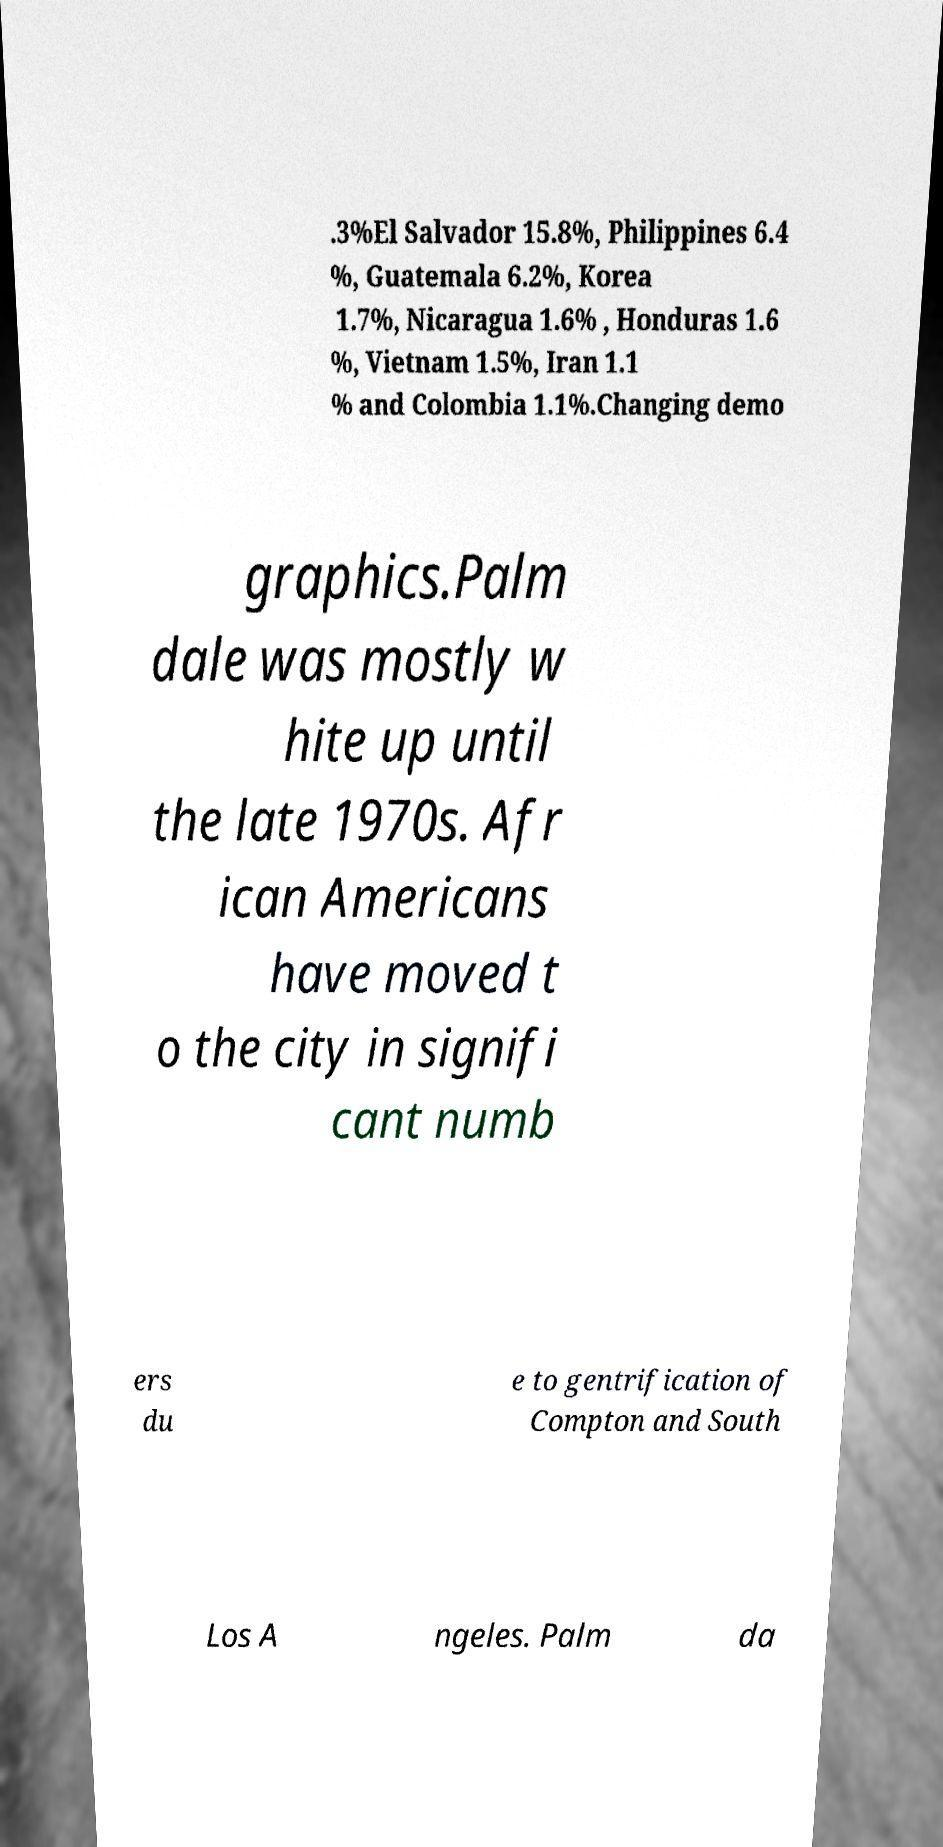For documentation purposes, I need the text within this image transcribed. Could you provide that? .3%El Salvador 15.8%, Philippines 6.4 %, Guatemala 6.2%, Korea 1.7%, Nicaragua 1.6% , Honduras 1.6 %, Vietnam 1.5%, Iran 1.1 % and Colombia 1.1%.Changing demo graphics.Palm dale was mostly w hite up until the late 1970s. Afr ican Americans have moved t o the city in signifi cant numb ers du e to gentrification of Compton and South Los A ngeles. Palm da 